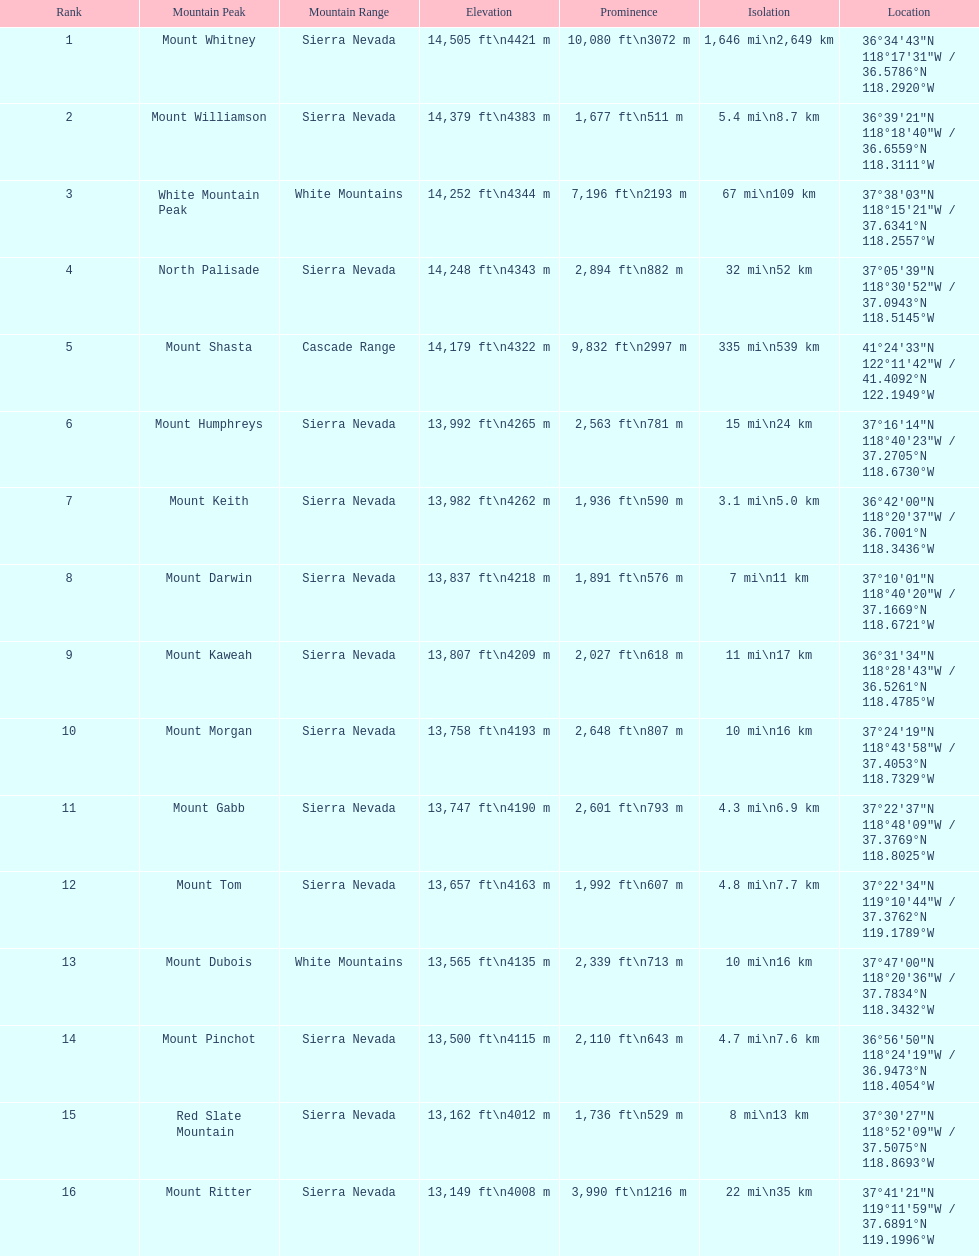Which mountain peak has the most isolation? Mount Whitney. 